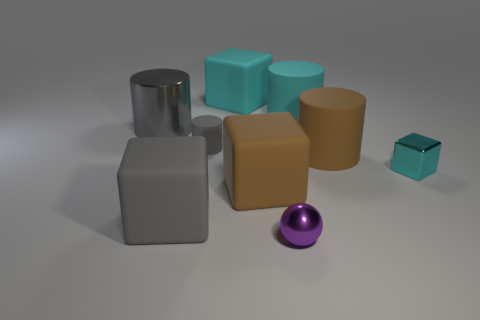Are there fewer metal cubes that are behind the big gray metallic cylinder than small cylinders in front of the gray matte block?
Your answer should be compact. No. There is a large block that is both in front of the cyan rubber block and right of the gray rubber block; what is it made of?
Your answer should be very brief. Rubber. There is a big gray shiny thing; is its shape the same as the small gray rubber object to the left of the purple sphere?
Offer a very short reply. Yes. How many other things are the same size as the gray metallic thing?
Give a very brief answer. 5. Are there more brown spheres than purple metal objects?
Your answer should be compact. No. What number of small objects are both to the left of the cyan matte cylinder and behind the small purple metallic sphere?
Give a very brief answer. 1. The big brown rubber object that is in front of the big cylinder that is in front of the tiny object that is behind the tiny cyan metal thing is what shape?
Ensure brevity in your answer.  Cube. Are there any other things that are the same shape as the purple metallic thing?
Your response must be concise. No. What number of cylinders are gray shiny objects or small matte objects?
Give a very brief answer. 2. Do the cube that is to the left of the small rubber cylinder and the metal cylinder have the same color?
Provide a succinct answer. Yes. 